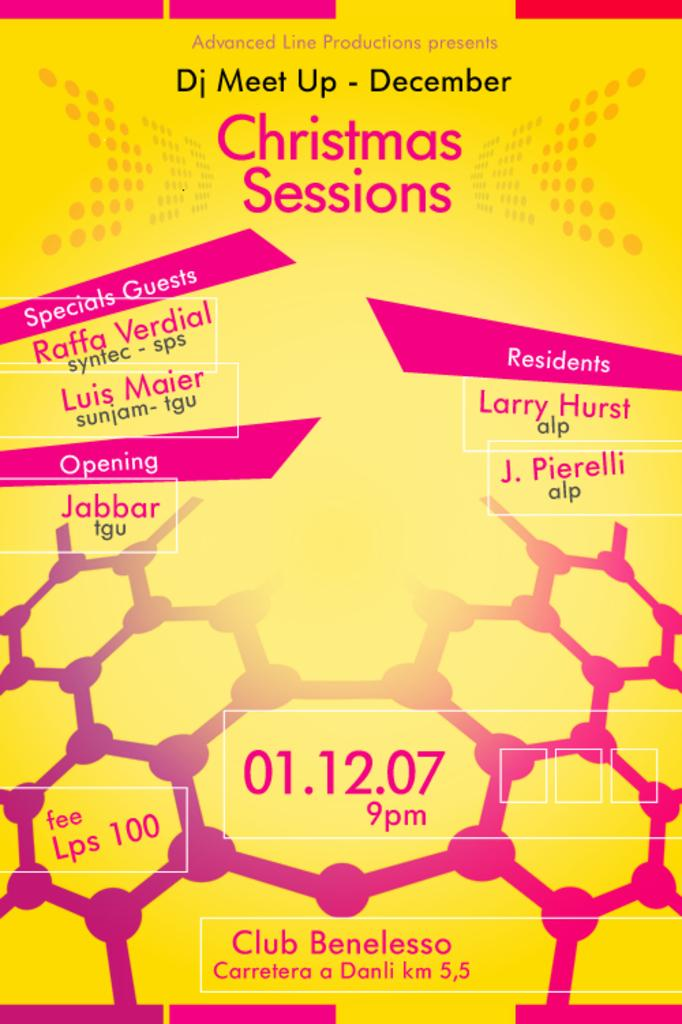<image>
Provide a brief description of the given image. a poster for DJ meet up December Christmas Sessions 